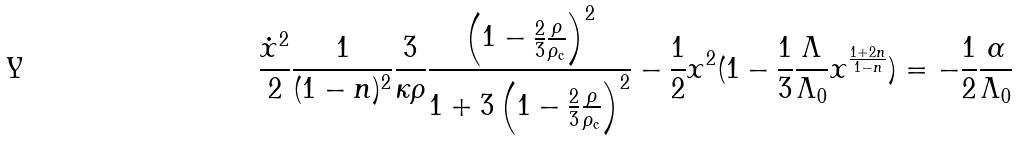<formula> <loc_0><loc_0><loc_500><loc_500>\frac { \dot { x } ^ { 2 } } { 2 } \frac { 1 } { ( 1 - n ) ^ { 2 } } \frac { 3 } { \kappa \rho } \frac { \left ( 1 - \frac { 2 } { 3 } \frac { \rho } { \rho _ { \text {c} } } \right ) ^ { 2 } } { 1 + 3 \left ( 1 - \frac { 2 } { 3 } \frac { \rho } { \rho _ { \text {c} } } \right ) ^ { 2 } } - \frac { 1 } { 2 } x ^ { 2 } ( 1 - \frac { 1 } { 3 } \frac { \Lambda } { \Lambda _ { 0 } } x ^ { \frac { 1 + 2 n } { 1 - n } } ) = - \frac { 1 } { 2 } \frac { \alpha } { \Lambda _ { 0 } }</formula> 